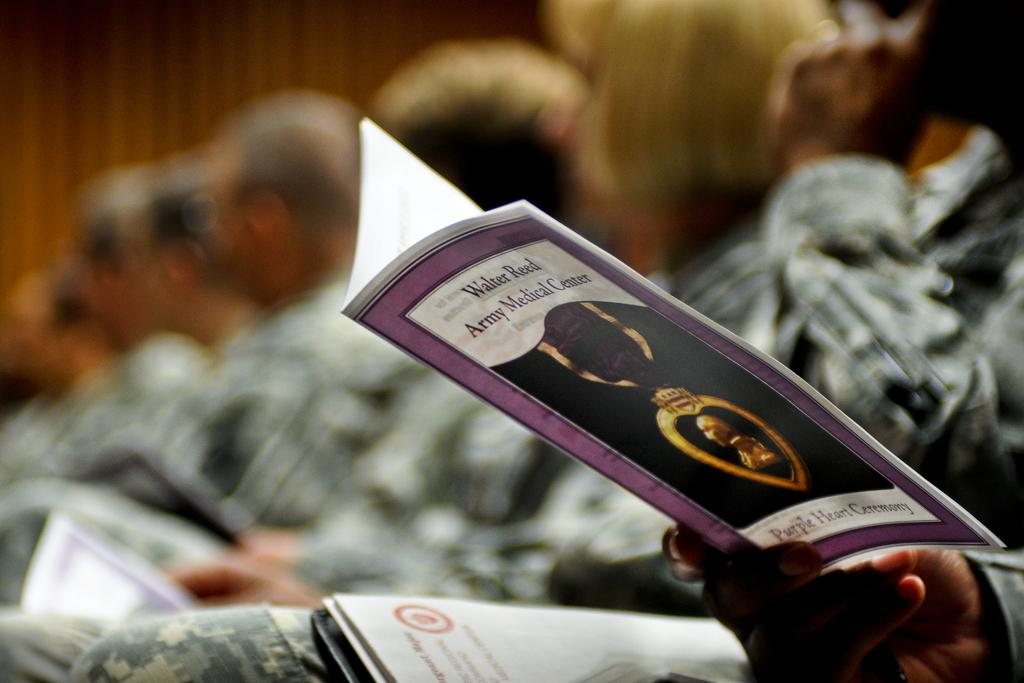<image>
Describe the image concisely. Someone holding a pamphlet that says Walter Reed Army Medical Center on it. 